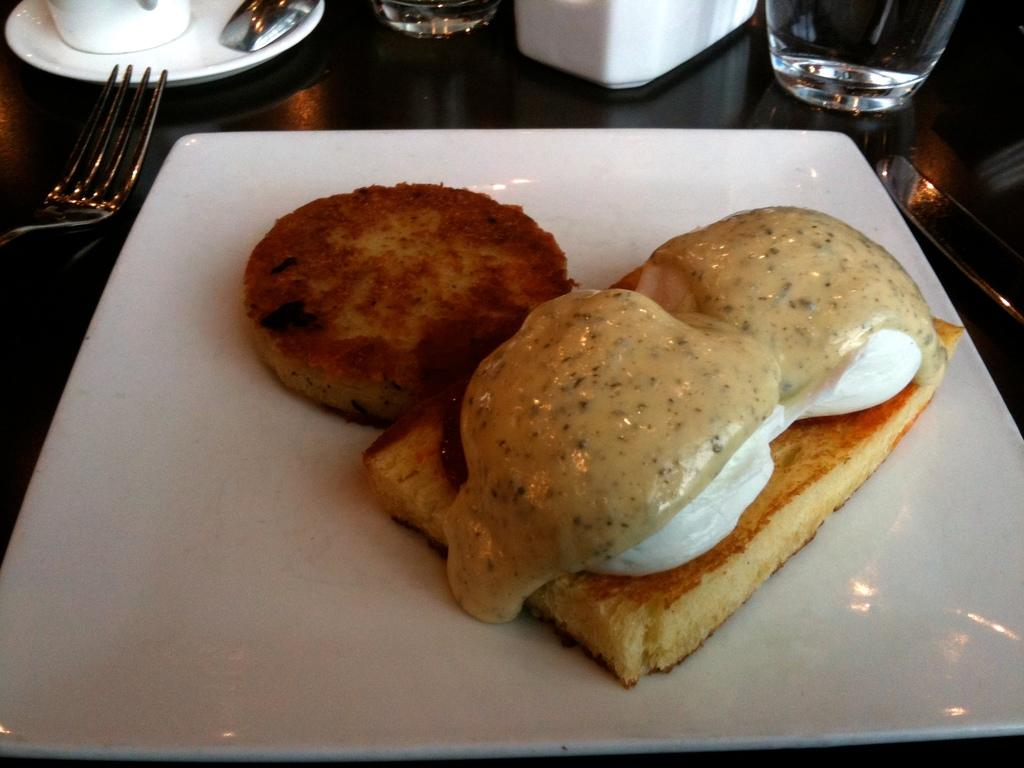What type of dishware is used to hold the food items in the image? There are food items on a white color plate in the image. What utensil is visible in the image? There is a fork visible in the image. What type of beverage container is present in the image? There is a glass in the image. What can be seen on the table in the image? There are objects on the table in the image. What direction is the veil blowing in the image? There is no veil present in the image. Can you see an airplane flying in the image? There is no airplane visible in the image. 